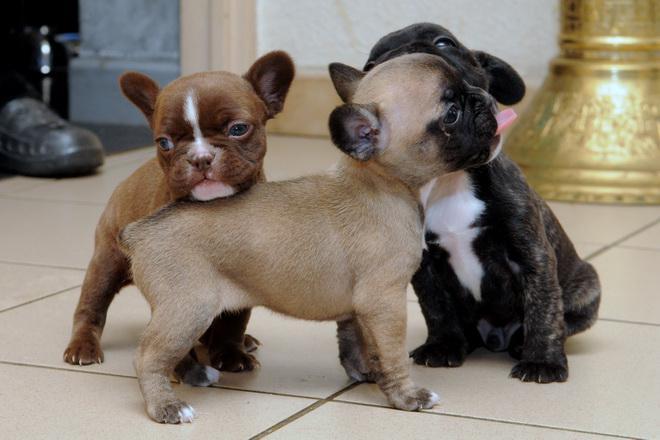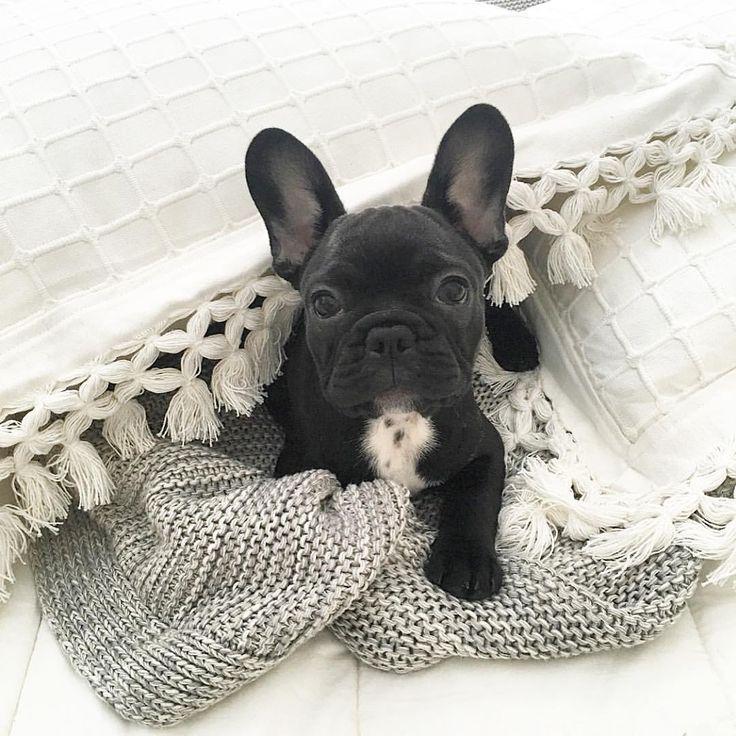The first image is the image on the left, the second image is the image on the right. For the images displayed, is the sentence "The right image contains exactly three dogs." factually correct? Answer yes or no. No. The first image is the image on the left, the second image is the image on the right. Examine the images to the left and right. Is the description "There are no more than five puppies in the pair of images." accurate? Answer yes or no. Yes. 